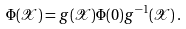Convert formula to latex. <formula><loc_0><loc_0><loc_500><loc_500>\Phi ( \mathcal { X } ) = g ( \mathcal { X } ) \Phi ( 0 ) g ^ { - 1 } ( \mathcal { X } ) \, .</formula> 